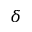Convert formula to latex. <formula><loc_0><loc_0><loc_500><loc_500>\delta</formula> 